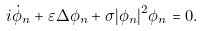Convert formula to latex. <formula><loc_0><loc_0><loc_500><loc_500>i \dot { \phi } _ { n } + \varepsilon \Delta \phi _ { n } + \sigma | \phi _ { n } | ^ { 2 } \phi _ { n } = 0 .</formula> 